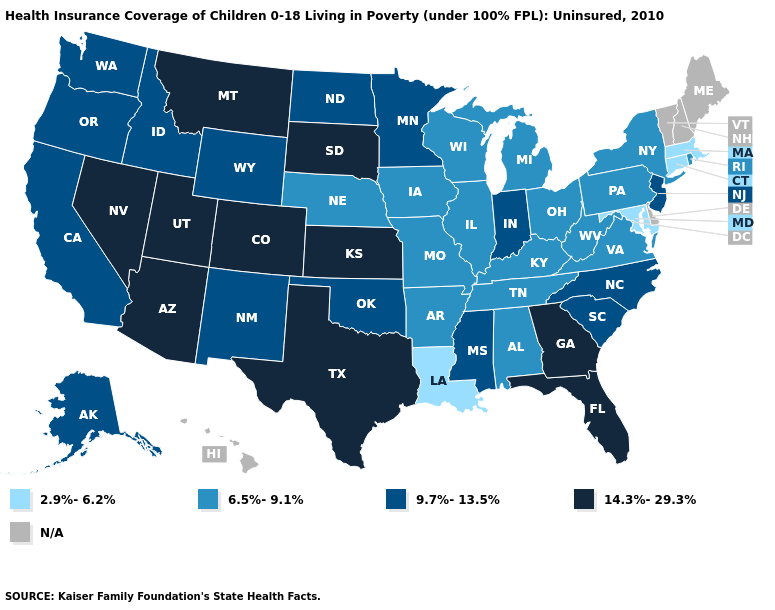Is the legend a continuous bar?
Give a very brief answer. No. What is the value of Connecticut?
Concise answer only. 2.9%-6.2%. Which states have the highest value in the USA?
Answer briefly. Arizona, Colorado, Florida, Georgia, Kansas, Montana, Nevada, South Dakota, Texas, Utah. How many symbols are there in the legend?
Keep it brief. 5. What is the value of Wyoming?
Answer briefly. 9.7%-13.5%. What is the value of Pennsylvania?
Give a very brief answer. 6.5%-9.1%. Does the map have missing data?
Write a very short answer. Yes. Is the legend a continuous bar?
Concise answer only. No. Name the states that have a value in the range 9.7%-13.5%?
Concise answer only. Alaska, California, Idaho, Indiana, Minnesota, Mississippi, New Jersey, New Mexico, North Carolina, North Dakota, Oklahoma, Oregon, South Carolina, Washington, Wyoming. Name the states that have a value in the range N/A?
Give a very brief answer. Delaware, Hawaii, Maine, New Hampshire, Vermont. What is the value of Mississippi?
Be succinct. 9.7%-13.5%. Which states have the highest value in the USA?
Quick response, please. Arizona, Colorado, Florida, Georgia, Kansas, Montana, Nevada, South Dakota, Texas, Utah. Among the states that border Wisconsin , which have the lowest value?
Concise answer only. Illinois, Iowa, Michigan. Is the legend a continuous bar?
Write a very short answer. No. Which states have the lowest value in the South?
Concise answer only. Louisiana, Maryland. 